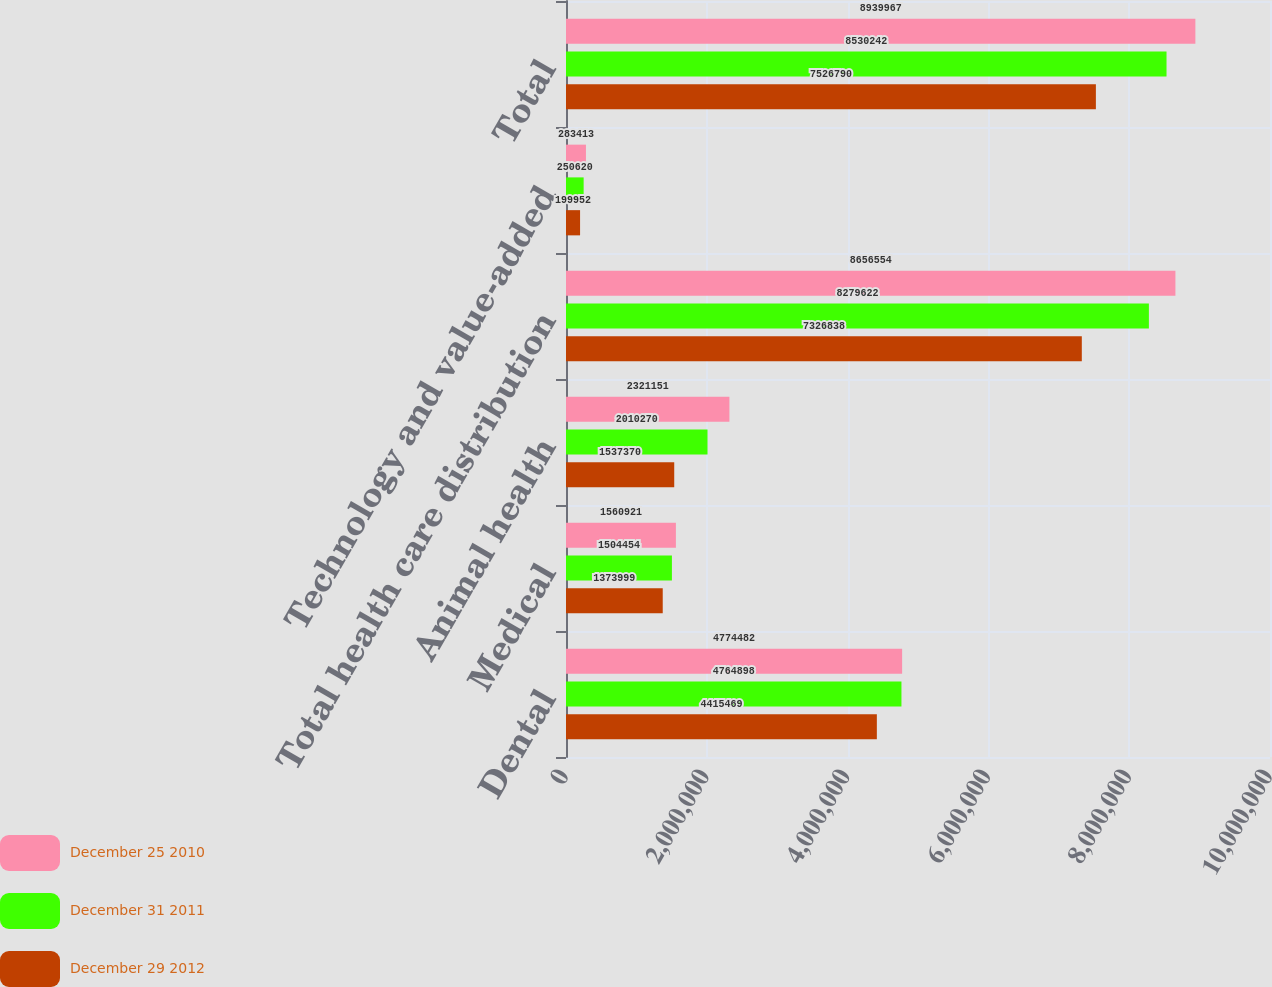<chart> <loc_0><loc_0><loc_500><loc_500><stacked_bar_chart><ecel><fcel>Dental<fcel>Medical<fcel>Animal health<fcel>Total health care distribution<fcel>Technology and value-added<fcel>Total<nl><fcel>December 25 2010<fcel>4.77448e+06<fcel>1.56092e+06<fcel>2.32115e+06<fcel>8.65655e+06<fcel>283413<fcel>8.93997e+06<nl><fcel>December 31 2011<fcel>4.7649e+06<fcel>1.50445e+06<fcel>2.01027e+06<fcel>8.27962e+06<fcel>250620<fcel>8.53024e+06<nl><fcel>December 29 2012<fcel>4.41547e+06<fcel>1.374e+06<fcel>1.53737e+06<fcel>7.32684e+06<fcel>199952<fcel>7.52679e+06<nl></chart> 